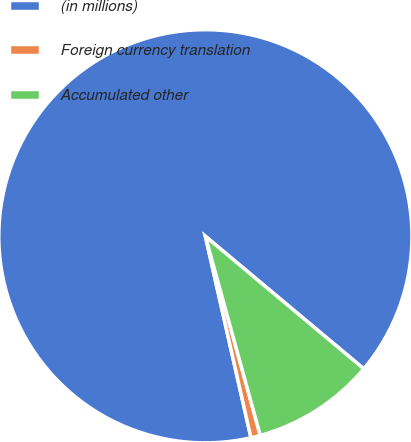Convert chart. <chart><loc_0><loc_0><loc_500><loc_500><pie_chart><fcel>(in millions)<fcel>Foreign currency translation<fcel>Accumulated other<nl><fcel>89.63%<fcel>0.74%<fcel>9.63%<nl></chart> 